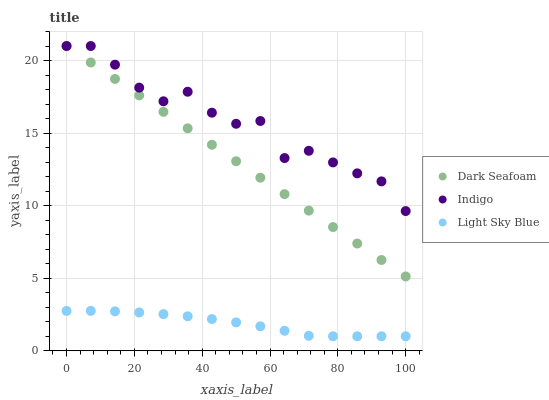Does Light Sky Blue have the minimum area under the curve?
Answer yes or no. Yes. Does Indigo have the maximum area under the curve?
Answer yes or no. Yes. Does Indigo have the minimum area under the curve?
Answer yes or no. No. Does Light Sky Blue have the maximum area under the curve?
Answer yes or no. No. Is Dark Seafoam the smoothest?
Answer yes or no. Yes. Is Indigo the roughest?
Answer yes or no. Yes. Is Light Sky Blue the smoothest?
Answer yes or no. No. Is Light Sky Blue the roughest?
Answer yes or no. No. Does Light Sky Blue have the lowest value?
Answer yes or no. Yes. Does Indigo have the lowest value?
Answer yes or no. No. Does Indigo have the highest value?
Answer yes or no. Yes. Does Light Sky Blue have the highest value?
Answer yes or no. No. Is Light Sky Blue less than Indigo?
Answer yes or no. Yes. Is Indigo greater than Light Sky Blue?
Answer yes or no. Yes. Does Dark Seafoam intersect Indigo?
Answer yes or no. Yes. Is Dark Seafoam less than Indigo?
Answer yes or no. No. Is Dark Seafoam greater than Indigo?
Answer yes or no. No. Does Light Sky Blue intersect Indigo?
Answer yes or no. No. 